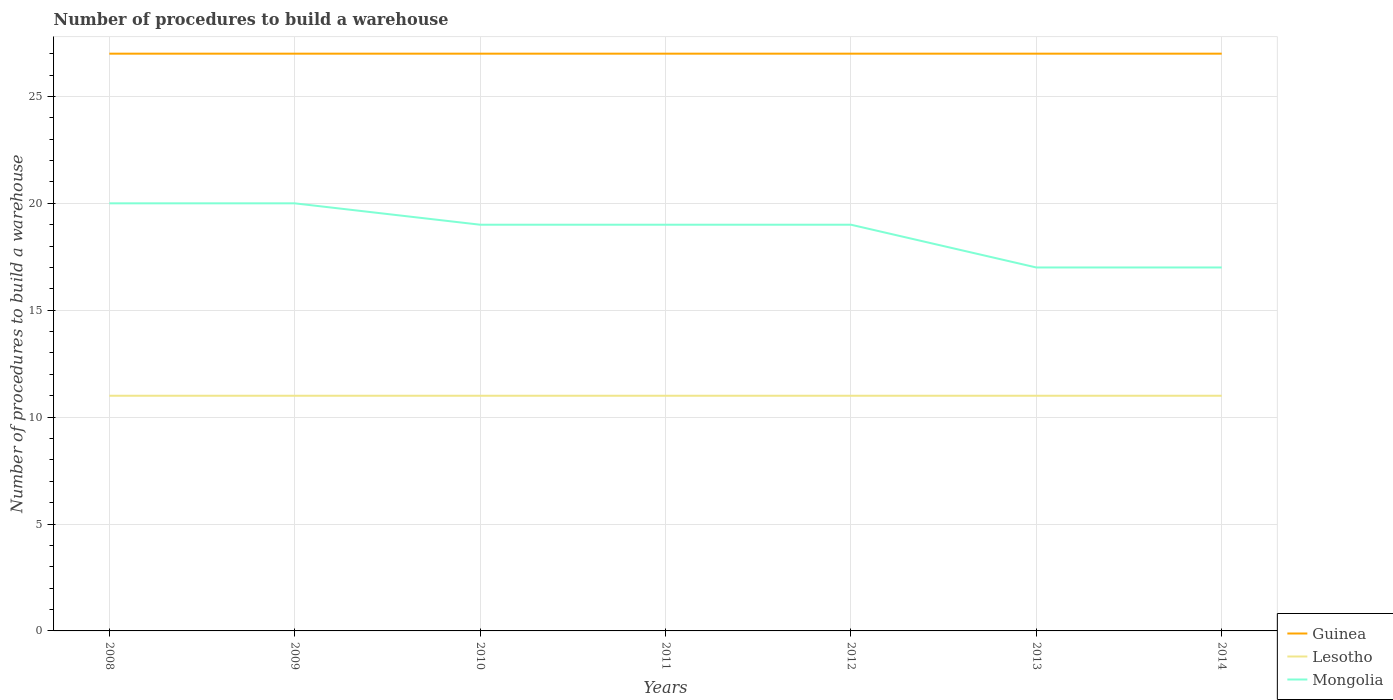Does the line corresponding to Guinea intersect with the line corresponding to Mongolia?
Keep it short and to the point. No. Across all years, what is the maximum number of procedures to build a warehouse in in Mongolia?
Keep it short and to the point. 17. What is the total number of procedures to build a warehouse in in Guinea in the graph?
Give a very brief answer. 0. What is the difference between the highest and the second highest number of procedures to build a warehouse in in Guinea?
Your response must be concise. 0. What is the difference between the highest and the lowest number of procedures to build a warehouse in in Mongolia?
Your response must be concise. 5. Are the values on the major ticks of Y-axis written in scientific E-notation?
Your answer should be compact. No. Does the graph contain grids?
Your answer should be compact. Yes. Where does the legend appear in the graph?
Make the answer very short. Bottom right. What is the title of the graph?
Your answer should be very brief. Number of procedures to build a warehouse. What is the label or title of the X-axis?
Give a very brief answer. Years. What is the label or title of the Y-axis?
Make the answer very short. Number of procedures to build a warehouse. What is the Number of procedures to build a warehouse in Lesotho in 2008?
Provide a succinct answer. 11. What is the Number of procedures to build a warehouse of Guinea in 2009?
Ensure brevity in your answer.  27. What is the Number of procedures to build a warehouse of Lesotho in 2009?
Provide a short and direct response. 11. What is the Number of procedures to build a warehouse of Mongolia in 2009?
Keep it short and to the point. 20. What is the Number of procedures to build a warehouse of Guinea in 2011?
Offer a very short reply. 27. What is the Number of procedures to build a warehouse in Mongolia in 2012?
Give a very brief answer. 19. What is the Number of procedures to build a warehouse in Mongolia in 2013?
Your answer should be compact. 17. What is the Number of procedures to build a warehouse in Guinea in 2014?
Your response must be concise. 27. What is the Number of procedures to build a warehouse in Mongolia in 2014?
Ensure brevity in your answer.  17. Across all years, what is the maximum Number of procedures to build a warehouse in Guinea?
Offer a terse response. 27. Across all years, what is the maximum Number of procedures to build a warehouse in Mongolia?
Give a very brief answer. 20. What is the total Number of procedures to build a warehouse in Guinea in the graph?
Your answer should be compact. 189. What is the total Number of procedures to build a warehouse of Mongolia in the graph?
Ensure brevity in your answer.  131. What is the difference between the Number of procedures to build a warehouse of Lesotho in 2008 and that in 2009?
Offer a terse response. 0. What is the difference between the Number of procedures to build a warehouse in Mongolia in 2008 and that in 2009?
Provide a succinct answer. 0. What is the difference between the Number of procedures to build a warehouse of Guinea in 2008 and that in 2010?
Provide a succinct answer. 0. What is the difference between the Number of procedures to build a warehouse in Mongolia in 2008 and that in 2010?
Ensure brevity in your answer.  1. What is the difference between the Number of procedures to build a warehouse in Guinea in 2008 and that in 2011?
Your answer should be compact. 0. What is the difference between the Number of procedures to build a warehouse in Guinea in 2008 and that in 2013?
Keep it short and to the point. 0. What is the difference between the Number of procedures to build a warehouse of Lesotho in 2008 and that in 2013?
Your response must be concise. 0. What is the difference between the Number of procedures to build a warehouse of Mongolia in 2008 and that in 2013?
Provide a succinct answer. 3. What is the difference between the Number of procedures to build a warehouse of Lesotho in 2008 and that in 2014?
Offer a terse response. 0. What is the difference between the Number of procedures to build a warehouse of Mongolia in 2008 and that in 2014?
Provide a short and direct response. 3. What is the difference between the Number of procedures to build a warehouse in Guinea in 2009 and that in 2010?
Your answer should be very brief. 0. What is the difference between the Number of procedures to build a warehouse in Lesotho in 2009 and that in 2010?
Offer a terse response. 0. What is the difference between the Number of procedures to build a warehouse of Mongolia in 2009 and that in 2010?
Offer a very short reply. 1. What is the difference between the Number of procedures to build a warehouse of Guinea in 2009 and that in 2011?
Give a very brief answer. 0. What is the difference between the Number of procedures to build a warehouse of Lesotho in 2009 and that in 2011?
Offer a terse response. 0. What is the difference between the Number of procedures to build a warehouse in Mongolia in 2009 and that in 2011?
Make the answer very short. 1. What is the difference between the Number of procedures to build a warehouse in Mongolia in 2009 and that in 2012?
Your response must be concise. 1. What is the difference between the Number of procedures to build a warehouse in Mongolia in 2009 and that in 2013?
Your answer should be compact. 3. What is the difference between the Number of procedures to build a warehouse of Guinea in 2009 and that in 2014?
Offer a very short reply. 0. What is the difference between the Number of procedures to build a warehouse of Lesotho in 2009 and that in 2014?
Keep it short and to the point. 0. What is the difference between the Number of procedures to build a warehouse in Mongolia in 2010 and that in 2011?
Your response must be concise. 0. What is the difference between the Number of procedures to build a warehouse of Guinea in 2010 and that in 2012?
Ensure brevity in your answer.  0. What is the difference between the Number of procedures to build a warehouse of Mongolia in 2010 and that in 2012?
Make the answer very short. 0. What is the difference between the Number of procedures to build a warehouse of Lesotho in 2010 and that in 2013?
Keep it short and to the point. 0. What is the difference between the Number of procedures to build a warehouse in Lesotho in 2010 and that in 2014?
Offer a terse response. 0. What is the difference between the Number of procedures to build a warehouse in Lesotho in 2011 and that in 2013?
Give a very brief answer. 0. What is the difference between the Number of procedures to build a warehouse of Guinea in 2011 and that in 2014?
Ensure brevity in your answer.  0. What is the difference between the Number of procedures to build a warehouse in Mongolia in 2011 and that in 2014?
Offer a terse response. 2. What is the difference between the Number of procedures to build a warehouse in Guinea in 2012 and that in 2014?
Keep it short and to the point. 0. What is the difference between the Number of procedures to build a warehouse in Mongolia in 2012 and that in 2014?
Your answer should be very brief. 2. What is the difference between the Number of procedures to build a warehouse in Lesotho in 2013 and that in 2014?
Offer a terse response. 0. What is the difference between the Number of procedures to build a warehouse in Guinea in 2008 and the Number of procedures to build a warehouse in Lesotho in 2009?
Your answer should be compact. 16. What is the difference between the Number of procedures to build a warehouse of Guinea in 2008 and the Number of procedures to build a warehouse of Mongolia in 2011?
Provide a short and direct response. 8. What is the difference between the Number of procedures to build a warehouse in Lesotho in 2008 and the Number of procedures to build a warehouse in Mongolia in 2013?
Your answer should be very brief. -6. What is the difference between the Number of procedures to build a warehouse in Guinea in 2008 and the Number of procedures to build a warehouse in Mongolia in 2014?
Offer a terse response. 10. What is the difference between the Number of procedures to build a warehouse in Lesotho in 2008 and the Number of procedures to build a warehouse in Mongolia in 2014?
Make the answer very short. -6. What is the difference between the Number of procedures to build a warehouse of Guinea in 2009 and the Number of procedures to build a warehouse of Lesotho in 2010?
Provide a succinct answer. 16. What is the difference between the Number of procedures to build a warehouse of Guinea in 2009 and the Number of procedures to build a warehouse of Mongolia in 2010?
Your answer should be compact. 8. What is the difference between the Number of procedures to build a warehouse of Guinea in 2009 and the Number of procedures to build a warehouse of Lesotho in 2011?
Your response must be concise. 16. What is the difference between the Number of procedures to build a warehouse of Lesotho in 2009 and the Number of procedures to build a warehouse of Mongolia in 2011?
Provide a short and direct response. -8. What is the difference between the Number of procedures to build a warehouse of Guinea in 2009 and the Number of procedures to build a warehouse of Mongolia in 2012?
Your response must be concise. 8. What is the difference between the Number of procedures to build a warehouse in Lesotho in 2009 and the Number of procedures to build a warehouse in Mongolia in 2012?
Offer a terse response. -8. What is the difference between the Number of procedures to build a warehouse in Guinea in 2009 and the Number of procedures to build a warehouse in Lesotho in 2013?
Provide a succinct answer. 16. What is the difference between the Number of procedures to build a warehouse in Lesotho in 2009 and the Number of procedures to build a warehouse in Mongolia in 2014?
Give a very brief answer. -6. What is the difference between the Number of procedures to build a warehouse of Guinea in 2010 and the Number of procedures to build a warehouse of Lesotho in 2011?
Make the answer very short. 16. What is the difference between the Number of procedures to build a warehouse in Guinea in 2010 and the Number of procedures to build a warehouse in Lesotho in 2012?
Your answer should be very brief. 16. What is the difference between the Number of procedures to build a warehouse of Guinea in 2010 and the Number of procedures to build a warehouse of Mongolia in 2012?
Make the answer very short. 8. What is the difference between the Number of procedures to build a warehouse in Lesotho in 2010 and the Number of procedures to build a warehouse in Mongolia in 2012?
Your response must be concise. -8. What is the difference between the Number of procedures to build a warehouse of Guinea in 2010 and the Number of procedures to build a warehouse of Lesotho in 2014?
Offer a terse response. 16. What is the difference between the Number of procedures to build a warehouse in Guinea in 2011 and the Number of procedures to build a warehouse in Lesotho in 2012?
Provide a short and direct response. 16. What is the difference between the Number of procedures to build a warehouse of Lesotho in 2011 and the Number of procedures to build a warehouse of Mongolia in 2013?
Your response must be concise. -6. What is the difference between the Number of procedures to build a warehouse in Guinea in 2011 and the Number of procedures to build a warehouse in Mongolia in 2014?
Offer a very short reply. 10. What is the difference between the Number of procedures to build a warehouse of Lesotho in 2011 and the Number of procedures to build a warehouse of Mongolia in 2014?
Make the answer very short. -6. What is the difference between the Number of procedures to build a warehouse of Guinea in 2012 and the Number of procedures to build a warehouse of Lesotho in 2013?
Provide a succinct answer. 16. What is the difference between the Number of procedures to build a warehouse in Guinea in 2012 and the Number of procedures to build a warehouse in Mongolia in 2013?
Your answer should be very brief. 10. What is the difference between the Number of procedures to build a warehouse of Lesotho in 2012 and the Number of procedures to build a warehouse of Mongolia in 2013?
Give a very brief answer. -6. What is the difference between the Number of procedures to build a warehouse in Guinea in 2012 and the Number of procedures to build a warehouse in Lesotho in 2014?
Offer a terse response. 16. What is the difference between the Number of procedures to build a warehouse in Guinea in 2012 and the Number of procedures to build a warehouse in Mongolia in 2014?
Offer a terse response. 10. What is the difference between the Number of procedures to build a warehouse in Lesotho in 2012 and the Number of procedures to build a warehouse in Mongolia in 2014?
Your response must be concise. -6. What is the difference between the Number of procedures to build a warehouse of Guinea in 2013 and the Number of procedures to build a warehouse of Lesotho in 2014?
Your answer should be very brief. 16. What is the difference between the Number of procedures to build a warehouse in Lesotho in 2013 and the Number of procedures to build a warehouse in Mongolia in 2014?
Make the answer very short. -6. What is the average Number of procedures to build a warehouse in Guinea per year?
Make the answer very short. 27. What is the average Number of procedures to build a warehouse of Lesotho per year?
Your answer should be very brief. 11. What is the average Number of procedures to build a warehouse of Mongolia per year?
Your answer should be compact. 18.71. In the year 2009, what is the difference between the Number of procedures to build a warehouse in Guinea and Number of procedures to build a warehouse in Lesotho?
Keep it short and to the point. 16. In the year 2009, what is the difference between the Number of procedures to build a warehouse in Guinea and Number of procedures to build a warehouse in Mongolia?
Ensure brevity in your answer.  7. In the year 2010, what is the difference between the Number of procedures to build a warehouse in Guinea and Number of procedures to build a warehouse in Lesotho?
Provide a succinct answer. 16. In the year 2010, what is the difference between the Number of procedures to build a warehouse of Guinea and Number of procedures to build a warehouse of Mongolia?
Offer a terse response. 8. In the year 2011, what is the difference between the Number of procedures to build a warehouse in Guinea and Number of procedures to build a warehouse in Mongolia?
Give a very brief answer. 8. In the year 2011, what is the difference between the Number of procedures to build a warehouse in Lesotho and Number of procedures to build a warehouse in Mongolia?
Offer a very short reply. -8. In the year 2012, what is the difference between the Number of procedures to build a warehouse in Guinea and Number of procedures to build a warehouse in Mongolia?
Provide a succinct answer. 8. In the year 2013, what is the difference between the Number of procedures to build a warehouse of Guinea and Number of procedures to build a warehouse of Mongolia?
Provide a succinct answer. 10. In the year 2014, what is the difference between the Number of procedures to build a warehouse in Guinea and Number of procedures to build a warehouse in Lesotho?
Your answer should be very brief. 16. What is the ratio of the Number of procedures to build a warehouse of Lesotho in 2008 to that in 2009?
Provide a short and direct response. 1. What is the ratio of the Number of procedures to build a warehouse of Mongolia in 2008 to that in 2009?
Offer a terse response. 1. What is the ratio of the Number of procedures to build a warehouse of Lesotho in 2008 to that in 2010?
Keep it short and to the point. 1. What is the ratio of the Number of procedures to build a warehouse of Mongolia in 2008 to that in 2010?
Provide a succinct answer. 1.05. What is the ratio of the Number of procedures to build a warehouse in Guinea in 2008 to that in 2011?
Offer a terse response. 1. What is the ratio of the Number of procedures to build a warehouse in Lesotho in 2008 to that in 2011?
Offer a very short reply. 1. What is the ratio of the Number of procedures to build a warehouse of Mongolia in 2008 to that in 2011?
Offer a very short reply. 1.05. What is the ratio of the Number of procedures to build a warehouse in Guinea in 2008 to that in 2012?
Give a very brief answer. 1. What is the ratio of the Number of procedures to build a warehouse in Mongolia in 2008 to that in 2012?
Your answer should be very brief. 1.05. What is the ratio of the Number of procedures to build a warehouse in Lesotho in 2008 to that in 2013?
Give a very brief answer. 1. What is the ratio of the Number of procedures to build a warehouse of Mongolia in 2008 to that in 2013?
Offer a very short reply. 1.18. What is the ratio of the Number of procedures to build a warehouse of Guinea in 2008 to that in 2014?
Your answer should be very brief. 1. What is the ratio of the Number of procedures to build a warehouse of Lesotho in 2008 to that in 2014?
Provide a short and direct response. 1. What is the ratio of the Number of procedures to build a warehouse of Mongolia in 2008 to that in 2014?
Your response must be concise. 1.18. What is the ratio of the Number of procedures to build a warehouse of Lesotho in 2009 to that in 2010?
Offer a terse response. 1. What is the ratio of the Number of procedures to build a warehouse in Mongolia in 2009 to that in 2010?
Offer a terse response. 1.05. What is the ratio of the Number of procedures to build a warehouse in Guinea in 2009 to that in 2011?
Keep it short and to the point. 1. What is the ratio of the Number of procedures to build a warehouse of Lesotho in 2009 to that in 2011?
Offer a terse response. 1. What is the ratio of the Number of procedures to build a warehouse of Mongolia in 2009 to that in 2011?
Offer a terse response. 1.05. What is the ratio of the Number of procedures to build a warehouse of Lesotho in 2009 to that in 2012?
Provide a short and direct response. 1. What is the ratio of the Number of procedures to build a warehouse in Mongolia in 2009 to that in 2012?
Provide a short and direct response. 1.05. What is the ratio of the Number of procedures to build a warehouse in Guinea in 2009 to that in 2013?
Offer a very short reply. 1. What is the ratio of the Number of procedures to build a warehouse in Mongolia in 2009 to that in 2013?
Provide a succinct answer. 1.18. What is the ratio of the Number of procedures to build a warehouse of Lesotho in 2009 to that in 2014?
Ensure brevity in your answer.  1. What is the ratio of the Number of procedures to build a warehouse in Mongolia in 2009 to that in 2014?
Keep it short and to the point. 1.18. What is the ratio of the Number of procedures to build a warehouse of Guinea in 2010 to that in 2012?
Keep it short and to the point. 1. What is the ratio of the Number of procedures to build a warehouse of Lesotho in 2010 to that in 2012?
Your answer should be very brief. 1. What is the ratio of the Number of procedures to build a warehouse in Guinea in 2010 to that in 2013?
Offer a terse response. 1. What is the ratio of the Number of procedures to build a warehouse in Lesotho in 2010 to that in 2013?
Ensure brevity in your answer.  1. What is the ratio of the Number of procedures to build a warehouse in Mongolia in 2010 to that in 2013?
Your answer should be compact. 1.12. What is the ratio of the Number of procedures to build a warehouse in Lesotho in 2010 to that in 2014?
Provide a short and direct response. 1. What is the ratio of the Number of procedures to build a warehouse in Mongolia in 2010 to that in 2014?
Provide a short and direct response. 1.12. What is the ratio of the Number of procedures to build a warehouse in Guinea in 2011 to that in 2012?
Your response must be concise. 1. What is the ratio of the Number of procedures to build a warehouse of Lesotho in 2011 to that in 2012?
Ensure brevity in your answer.  1. What is the ratio of the Number of procedures to build a warehouse in Mongolia in 2011 to that in 2013?
Offer a very short reply. 1.12. What is the ratio of the Number of procedures to build a warehouse of Guinea in 2011 to that in 2014?
Offer a terse response. 1. What is the ratio of the Number of procedures to build a warehouse in Mongolia in 2011 to that in 2014?
Your response must be concise. 1.12. What is the ratio of the Number of procedures to build a warehouse in Lesotho in 2012 to that in 2013?
Your answer should be compact. 1. What is the ratio of the Number of procedures to build a warehouse of Mongolia in 2012 to that in 2013?
Give a very brief answer. 1.12. What is the ratio of the Number of procedures to build a warehouse of Guinea in 2012 to that in 2014?
Give a very brief answer. 1. What is the ratio of the Number of procedures to build a warehouse in Lesotho in 2012 to that in 2014?
Keep it short and to the point. 1. What is the ratio of the Number of procedures to build a warehouse in Mongolia in 2012 to that in 2014?
Your answer should be very brief. 1.12. What is the ratio of the Number of procedures to build a warehouse in Guinea in 2013 to that in 2014?
Ensure brevity in your answer.  1. What is the ratio of the Number of procedures to build a warehouse of Lesotho in 2013 to that in 2014?
Ensure brevity in your answer.  1. What is the ratio of the Number of procedures to build a warehouse of Mongolia in 2013 to that in 2014?
Your response must be concise. 1. What is the difference between the highest and the second highest Number of procedures to build a warehouse of Mongolia?
Ensure brevity in your answer.  0. 